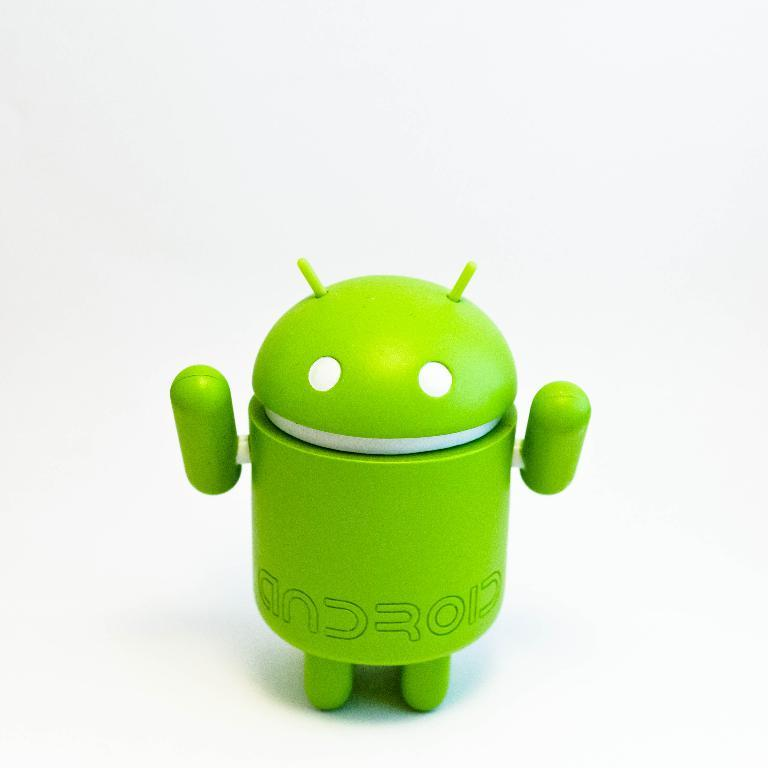<image>
Offer a succinct explanation of the picture presented. A green android figure that has white eyes and mouth 